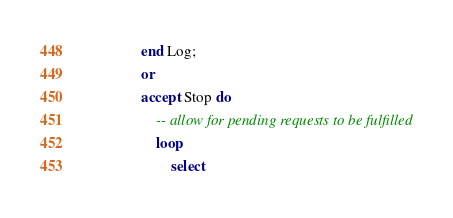Convert code to text. <code><loc_0><loc_0><loc_500><loc_500><_Ada_>                end Log;
                or
                accept Stop do
                    -- allow for pending requests to be fulfilled
                    loop
                        select</code> 